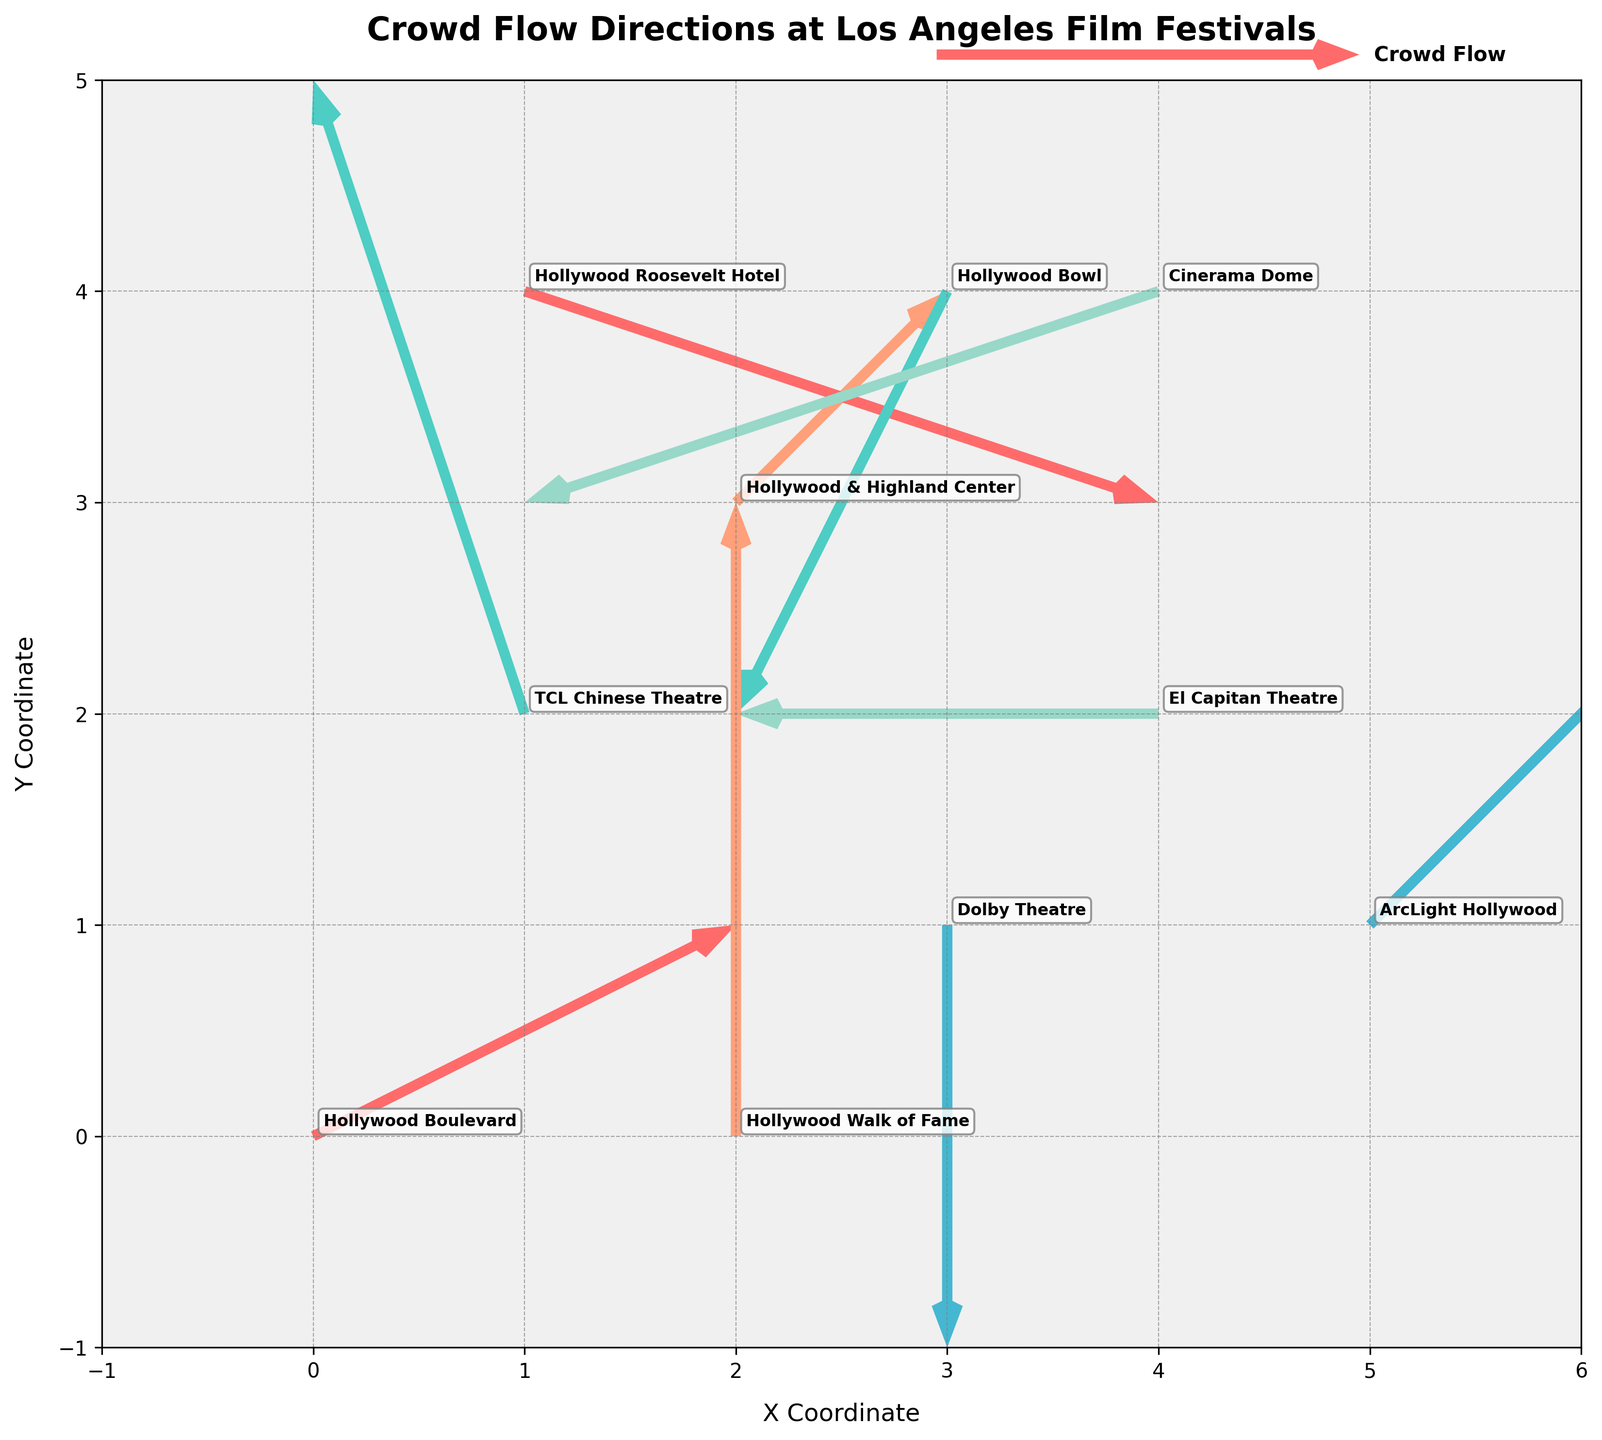What is the title of the plot? The title is indicated at the top of the plot.
Answer: Crowd Flow Directions at Los Angeles Film Festivals Which location has the strongest crowd flow in the positive x-direction? By looking at the arrows, the one with the largest positive x-component (u) is at the Hollywood Roosevelt Hotel.
Answer: Hollywood Roosevelt Hotel What are the x and y coordinates of Dolby Theatre? The coordinates are located near the location label on the plot.
Answer: x=3, y=1 How many locations have a negative y-direction flow? By observing the y-component (v) of the arrows, the locations with negative values are Dolby Theatre, Hollywood Bowl, Cinerama Dome, and Hollywood Roosevelt Hotel.
Answer: 4 locations Between TCL Chinese Theatre and Dolby Theatre, which has a larger magnitude in crowd flow? Calculate the magnitude for both by using sqrt(u^2 + v^2): for TCL Chinese Theatre, it's sqrt((-1)^2 + (3)^2) = sqrt(10); for Dolby Theatre, it's sqrt((0)^2 + (-2)^2) = sqrt(4). Therefore, TCL Chinese Theatre has a larger magnitude.
Answer: TCL Chinese Theatre What is the direction of the crowd flow at El Capitan Theatre? The direction of the flow can be determined by the arrow's components (-2, 0), meaning it is directly to the left (negative x-direction).
Answer: Left Which location has a crowd flow vector of (0, 3)? Locate the vector with these components on the plot, which is the Hollywood Walk of Fame.
Answer: Hollywood Walk of Fame How many arrows on the plot point upwards? By counting the arrows with a positive y-component. The locations with positive y-components are Hollywood Boulevard, TCL Chinese Theatre, Hollywood & Highland Center, Hollywood Walk of Fame, and ArcLight Hollywood.
Answer: 5 arrows Compare the crowd flow magnitude at Hollywood Boulevard and Cinerama Dome. Which is stronger? Calculate the magnitude for both by using sqrt(u^2 + v^2): for Hollywood Boulevard, it's sqrt((2)^2 + (1)^2) = sqrt(5); for Cinerama Dome, it's sqrt((-3)^2 + (-1)^2) = sqrt(10). Therefore, Cinerama Dome has a stronger crowd flow.
Answer: Cinerama Dome Which location is represented by the quiver arrow at coordinates (1, 4)? Check the plot to see which location label corresponds to these coordinates.
Answer: Hollywood Roosevelt Hotel 